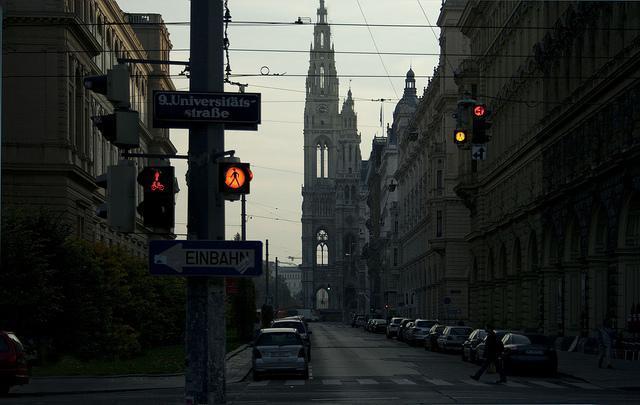How many cars can you see?
Give a very brief answer. 2. How many traffic lights are in the photo?
Give a very brief answer. 3. 